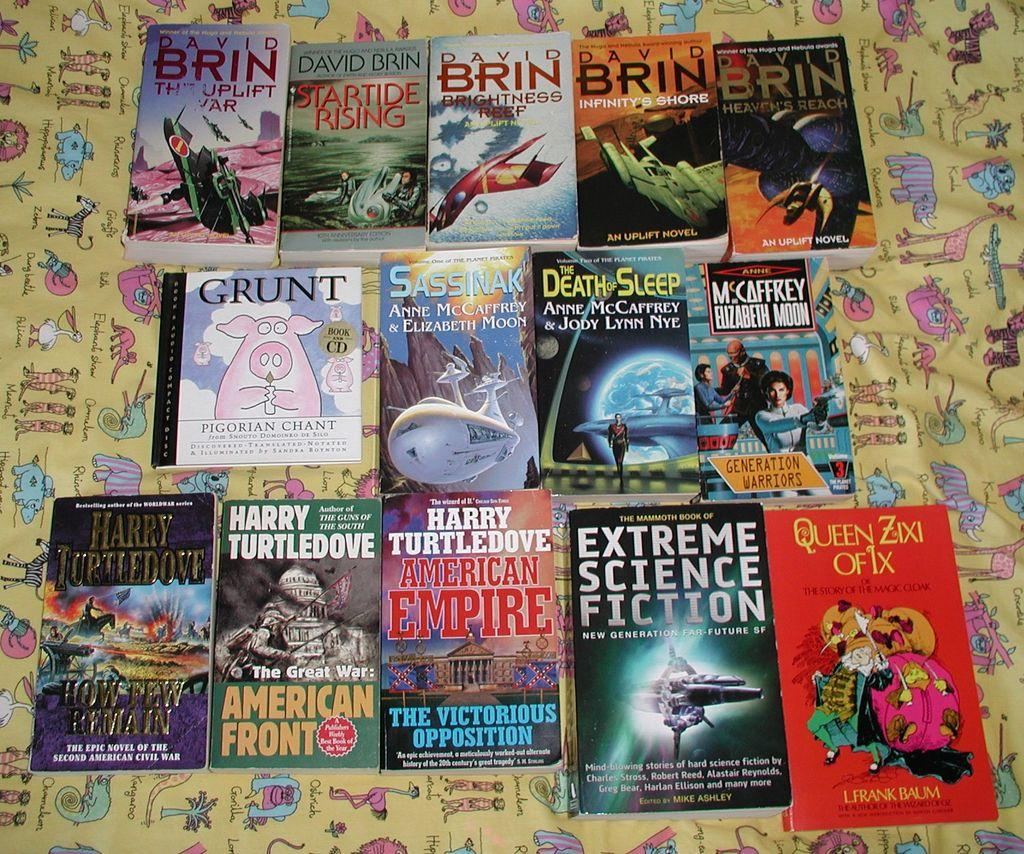<image>
Give a short and clear explanation of the subsequent image. A variety of books including Extreme Science Fiction, Death Sleep, and David Brin books among others. 